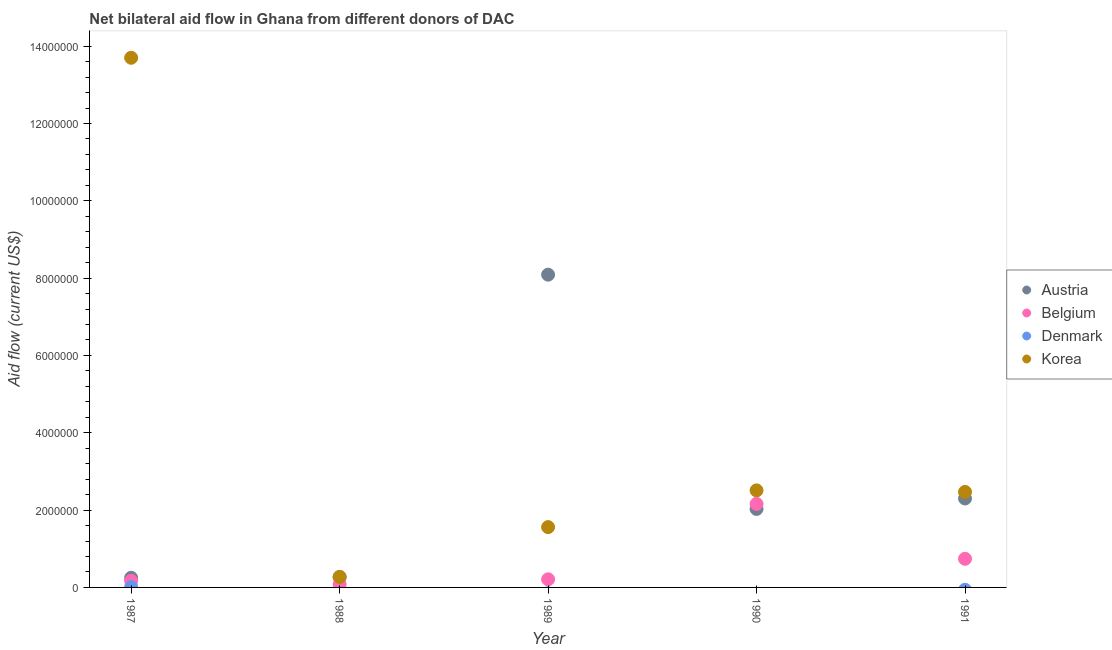How many different coloured dotlines are there?
Offer a very short reply. 4. What is the amount of aid given by belgium in 1988?
Your response must be concise. 8.00e+04. Across all years, what is the maximum amount of aid given by austria?
Offer a terse response. 8.09e+06. What is the total amount of aid given by denmark in the graph?
Your response must be concise. 10000. What is the difference between the amount of aid given by korea in 1987 and that in 1989?
Your answer should be very brief. 1.21e+07. What is the difference between the amount of aid given by denmark in 1987 and the amount of aid given by austria in 1991?
Provide a short and direct response. -2.29e+06. What is the average amount of aid given by denmark per year?
Offer a very short reply. 2000. In the year 1989, what is the difference between the amount of aid given by belgium and amount of aid given by korea?
Your answer should be very brief. -1.35e+06. What is the ratio of the amount of aid given by belgium in 1989 to that in 1990?
Your answer should be compact. 0.1. Is the amount of aid given by korea in 1990 less than that in 1991?
Offer a very short reply. No. What is the difference between the highest and the second highest amount of aid given by korea?
Give a very brief answer. 1.12e+07. What is the difference between the highest and the lowest amount of aid given by korea?
Your answer should be compact. 1.34e+07. In how many years, is the amount of aid given by korea greater than the average amount of aid given by korea taken over all years?
Keep it short and to the point. 1. Is the sum of the amount of aid given by korea in 1987 and 1990 greater than the maximum amount of aid given by belgium across all years?
Make the answer very short. Yes. Is it the case that in every year, the sum of the amount of aid given by denmark and amount of aid given by austria is greater than the sum of amount of aid given by belgium and amount of aid given by korea?
Give a very brief answer. No. Is the amount of aid given by denmark strictly greater than the amount of aid given by belgium over the years?
Ensure brevity in your answer.  No. Is the amount of aid given by belgium strictly less than the amount of aid given by austria over the years?
Provide a short and direct response. No. How many dotlines are there?
Provide a succinct answer. 4. Are the values on the major ticks of Y-axis written in scientific E-notation?
Provide a succinct answer. No. Does the graph contain any zero values?
Keep it short and to the point. Yes. Does the graph contain grids?
Your answer should be very brief. No. Where does the legend appear in the graph?
Your response must be concise. Center right. How are the legend labels stacked?
Give a very brief answer. Vertical. What is the title of the graph?
Your answer should be compact. Net bilateral aid flow in Ghana from different donors of DAC. Does "Secondary general" appear as one of the legend labels in the graph?
Your answer should be compact. No. What is the label or title of the Y-axis?
Ensure brevity in your answer.  Aid flow (current US$). What is the Aid flow (current US$) of Austria in 1987?
Give a very brief answer. 2.50e+05. What is the Aid flow (current US$) of Denmark in 1987?
Provide a succinct answer. 10000. What is the Aid flow (current US$) of Korea in 1987?
Provide a succinct answer. 1.37e+07. What is the Aid flow (current US$) in Austria in 1988?
Your answer should be very brief. 2.70e+05. What is the Aid flow (current US$) in Belgium in 1988?
Give a very brief answer. 8.00e+04. What is the Aid flow (current US$) in Denmark in 1988?
Keep it short and to the point. 0. What is the Aid flow (current US$) of Austria in 1989?
Your answer should be very brief. 8.09e+06. What is the Aid flow (current US$) of Belgium in 1989?
Provide a short and direct response. 2.10e+05. What is the Aid flow (current US$) of Korea in 1989?
Your answer should be very brief. 1.56e+06. What is the Aid flow (current US$) of Austria in 1990?
Give a very brief answer. 2.03e+06. What is the Aid flow (current US$) in Belgium in 1990?
Keep it short and to the point. 2.16e+06. What is the Aid flow (current US$) of Korea in 1990?
Give a very brief answer. 2.51e+06. What is the Aid flow (current US$) in Austria in 1991?
Your answer should be compact. 2.30e+06. What is the Aid flow (current US$) of Belgium in 1991?
Ensure brevity in your answer.  7.40e+05. What is the Aid flow (current US$) in Denmark in 1991?
Make the answer very short. 0. What is the Aid flow (current US$) in Korea in 1991?
Offer a very short reply. 2.47e+06. Across all years, what is the maximum Aid flow (current US$) of Austria?
Your answer should be compact. 8.09e+06. Across all years, what is the maximum Aid flow (current US$) in Belgium?
Your answer should be compact. 2.16e+06. Across all years, what is the maximum Aid flow (current US$) in Korea?
Ensure brevity in your answer.  1.37e+07. Across all years, what is the minimum Aid flow (current US$) of Belgium?
Ensure brevity in your answer.  8.00e+04. Across all years, what is the minimum Aid flow (current US$) in Denmark?
Offer a very short reply. 0. Across all years, what is the minimum Aid flow (current US$) in Korea?
Ensure brevity in your answer.  2.70e+05. What is the total Aid flow (current US$) of Austria in the graph?
Your response must be concise. 1.29e+07. What is the total Aid flow (current US$) in Belgium in the graph?
Your answer should be compact. 3.36e+06. What is the total Aid flow (current US$) in Korea in the graph?
Your answer should be compact. 2.05e+07. What is the difference between the Aid flow (current US$) in Austria in 1987 and that in 1988?
Keep it short and to the point. -2.00e+04. What is the difference between the Aid flow (current US$) in Korea in 1987 and that in 1988?
Provide a short and direct response. 1.34e+07. What is the difference between the Aid flow (current US$) of Austria in 1987 and that in 1989?
Keep it short and to the point. -7.84e+06. What is the difference between the Aid flow (current US$) of Korea in 1987 and that in 1989?
Ensure brevity in your answer.  1.21e+07. What is the difference between the Aid flow (current US$) in Austria in 1987 and that in 1990?
Give a very brief answer. -1.78e+06. What is the difference between the Aid flow (current US$) of Belgium in 1987 and that in 1990?
Keep it short and to the point. -1.99e+06. What is the difference between the Aid flow (current US$) in Korea in 1987 and that in 1990?
Give a very brief answer. 1.12e+07. What is the difference between the Aid flow (current US$) of Austria in 1987 and that in 1991?
Give a very brief answer. -2.05e+06. What is the difference between the Aid flow (current US$) in Belgium in 1987 and that in 1991?
Make the answer very short. -5.70e+05. What is the difference between the Aid flow (current US$) of Korea in 1987 and that in 1991?
Keep it short and to the point. 1.12e+07. What is the difference between the Aid flow (current US$) of Austria in 1988 and that in 1989?
Provide a short and direct response. -7.82e+06. What is the difference between the Aid flow (current US$) in Korea in 1988 and that in 1989?
Keep it short and to the point. -1.29e+06. What is the difference between the Aid flow (current US$) in Austria in 1988 and that in 1990?
Your response must be concise. -1.76e+06. What is the difference between the Aid flow (current US$) of Belgium in 1988 and that in 1990?
Offer a terse response. -2.08e+06. What is the difference between the Aid flow (current US$) in Korea in 1988 and that in 1990?
Offer a very short reply. -2.24e+06. What is the difference between the Aid flow (current US$) in Austria in 1988 and that in 1991?
Your answer should be compact. -2.03e+06. What is the difference between the Aid flow (current US$) of Belgium in 1988 and that in 1991?
Offer a terse response. -6.60e+05. What is the difference between the Aid flow (current US$) of Korea in 1988 and that in 1991?
Ensure brevity in your answer.  -2.20e+06. What is the difference between the Aid flow (current US$) in Austria in 1989 and that in 1990?
Your answer should be compact. 6.06e+06. What is the difference between the Aid flow (current US$) in Belgium in 1989 and that in 1990?
Provide a short and direct response. -1.95e+06. What is the difference between the Aid flow (current US$) in Korea in 1989 and that in 1990?
Offer a terse response. -9.50e+05. What is the difference between the Aid flow (current US$) of Austria in 1989 and that in 1991?
Offer a terse response. 5.79e+06. What is the difference between the Aid flow (current US$) of Belgium in 1989 and that in 1991?
Your answer should be very brief. -5.30e+05. What is the difference between the Aid flow (current US$) of Korea in 1989 and that in 1991?
Your answer should be compact. -9.10e+05. What is the difference between the Aid flow (current US$) of Belgium in 1990 and that in 1991?
Keep it short and to the point. 1.42e+06. What is the difference between the Aid flow (current US$) of Korea in 1990 and that in 1991?
Your answer should be very brief. 4.00e+04. What is the difference between the Aid flow (current US$) in Austria in 1987 and the Aid flow (current US$) in Belgium in 1988?
Keep it short and to the point. 1.70e+05. What is the difference between the Aid flow (current US$) in Austria in 1987 and the Aid flow (current US$) in Belgium in 1989?
Your answer should be compact. 4.00e+04. What is the difference between the Aid flow (current US$) of Austria in 1987 and the Aid flow (current US$) of Korea in 1989?
Your answer should be compact. -1.31e+06. What is the difference between the Aid flow (current US$) of Belgium in 1987 and the Aid flow (current US$) of Korea in 1989?
Offer a terse response. -1.39e+06. What is the difference between the Aid flow (current US$) in Denmark in 1987 and the Aid flow (current US$) in Korea in 1989?
Provide a succinct answer. -1.55e+06. What is the difference between the Aid flow (current US$) in Austria in 1987 and the Aid flow (current US$) in Belgium in 1990?
Your answer should be very brief. -1.91e+06. What is the difference between the Aid flow (current US$) in Austria in 1987 and the Aid flow (current US$) in Korea in 1990?
Provide a short and direct response. -2.26e+06. What is the difference between the Aid flow (current US$) of Belgium in 1987 and the Aid flow (current US$) of Korea in 1990?
Provide a succinct answer. -2.34e+06. What is the difference between the Aid flow (current US$) of Denmark in 1987 and the Aid flow (current US$) of Korea in 1990?
Offer a terse response. -2.50e+06. What is the difference between the Aid flow (current US$) of Austria in 1987 and the Aid flow (current US$) of Belgium in 1991?
Offer a terse response. -4.90e+05. What is the difference between the Aid flow (current US$) of Austria in 1987 and the Aid flow (current US$) of Korea in 1991?
Ensure brevity in your answer.  -2.22e+06. What is the difference between the Aid flow (current US$) in Belgium in 1987 and the Aid flow (current US$) in Korea in 1991?
Offer a terse response. -2.30e+06. What is the difference between the Aid flow (current US$) of Denmark in 1987 and the Aid flow (current US$) of Korea in 1991?
Keep it short and to the point. -2.46e+06. What is the difference between the Aid flow (current US$) of Austria in 1988 and the Aid flow (current US$) of Belgium in 1989?
Give a very brief answer. 6.00e+04. What is the difference between the Aid flow (current US$) in Austria in 1988 and the Aid flow (current US$) in Korea in 1989?
Your answer should be very brief. -1.29e+06. What is the difference between the Aid flow (current US$) of Belgium in 1988 and the Aid flow (current US$) of Korea in 1989?
Your answer should be compact. -1.48e+06. What is the difference between the Aid flow (current US$) in Austria in 1988 and the Aid flow (current US$) in Belgium in 1990?
Offer a terse response. -1.89e+06. What is the difference between the Aid flow (current US$) of Austria in 1988 and the Aid flow (current US$) of Korea in 1990?
Keep it short and to the point. -2.24e+06. What is the difference between the Aid flow (current US$) in Belgium in 1988 and the Aid flow (current US$) in Korea in 1990?
Offer a very short reply. -2.43e+06. What is the difference between the Aid flow (current US$) in Austria in 1988 and the Aid flow (current US$) in Belgium in 1991?
Ensure brevity in your answer.  -4.70e+05. What is the difference between the Aid flow (current US$) of Austria in 1988 and the Aid flow (current US$) of Korea in 1991?
Provide a succinct answer. -2.20e+06. What is the difference between the Aid flow (current US$) in Belgium in 1988 and the Aid flow (current US$) in Korea in 1991?
Offer a very short reply. -2.39e+06. What is the difference between the Aid flow (current US$) of Austria in 1989 and the Aid flow (current US$) of Belgium in 1990?
Ensure brevity in your answer.  5.93e+06. What is the difference between the Aid flow (current US$) of Austria in 1989 and the Aid flow (current US$) of Korea in 1990?
Offer a terse response. 5.58e+06. What is the difference between the Aid flow (current US$) of Belgium in 1989 and the Aid flow (current US$) of Korea in 1990?
Offer a terse response. -2.30e+06. What is the difference between the Aid flow (current US$) in Austria in 1989 and the Aid flow (current US$) in Belgium in 1991?
Make the answer very short. 7.35e+06. What is the difference between the Aid flow (current US$) of Austria in 1989 and the Aid flow (current US$) of Korea in 1991?
Provide a short and direct response. 5.62e+06. What is the difference between the Aid flow (current US$) of Belgium in 1989 and the Aid flow (current US$) of Korea in 1991?
Provide a succinct answer. -2.26e+06. What is the difference between the Aid flow (current US$) in Austria in 1990 and the Aid flow (current US$) in Belgium in 1991?
Your response must be concise. 1.29e+06. What is the difference between the Aid flow (current US$) in Austria in 1990 and the Aid flow (current US$) in Korea in 1991?
Your response must be concise. -4.40e+05. What is the difference between the Aid flow (current US$) of Belgium in 1990 and the Aid flow (current US$) of Korea in 1991?
Make the answer very short. -3.10e+05. What is the average Aid flow (current US$) in Austria per year?
Ensure brevity in your answer.  2.59e+06. What is the average Aid flow (current US$) of Belgium per year?
Offer a very short reply. 6.72e+05. What is the average Aid flow (current US$) in Korea per year?
Offer a very short reply. 4.10e+06. In the year 1987, what is the difference between the Aid flow (current US$) in Austria and Aid flow (current US$) in Belgium?
Offer a very short reply. 8.00e+04. In the year 1987, what is the difference between the Aid flow (current US$) in Austria and Aid flow (current US$) in Korea?
Ensure brevity in your answer.  -1.34e+07. In the year 1987, what is the difference between the Aid flow (current US$) of Belgium and Aid flow (current US$) of Denmark?
Make the answer very short. 1.60e+05. In the year 1987, what is the difference between the Aid flow (current US$) of Belgium and Aid flow (current US$) of Korea?
Offer a terse response. -1.35e+07. In the year 1987, what is the difference between the Aid flow (current US$) of Denmark and Aid flow (current US$) of Korea?
Your answer should be very brief. -1.37e+07. In the year 1988, what is the difference between the Aid flow (current US$) in Austria and Aid flow (current US$) in Belgium?
Your answer should be very brief. 1.90e+05. In the year 1988, what is the difference between the Aid flow (current US$) of Austria and Aid flow (current US$) of Korea?
Provide a short and direct response. 0. In the year 1988, what is the difference between the Aid flow (current US$) of Belgium and Aid flow (current US$) of Korea?
Provide a short and direct response. -1.90e+05. In the year 1989, what is the difference between the Aid flow (current US$) in Austria and Aid flow (current US$) in Belgium?
Offer a very short reply. 7.88e+06. In the year 1989, what is the difference between the Aid flow (current US$) of Austria and Aid flow (current US$) of Korea?
Your answer should be compact. 6.53e+06. In the year 1989, what is the difference between the Aid flow (current US$) in Belgium and Aid flow (current US$) in Korea?
Provide a short and direct response. -1.35e+06. In the year 1990, what is the difference between the Aid flow (current US$) in Austria and Aid flow (current US$) in Korea?
Provide a short and direct response. -4.80e+05. In the year 1990, what is the difference between the Aid flow (current US$) of Belgium and Aid flow (current US$) of Korea?
Offer a terse response. -3.50e+05. In the year 1991, what is the difference between the Aid flow (current US$) in Austria and Aid flow (current US$) in Belgium?
Offer a terse response. 1.56e+06. In the year 1991, what is the difference between the Aid flow (current US$) of Belgium and Aid flow (current US$) of Korea?
Give a very brief answer. -1.73e+06. What is the ratio of the Aid flow (current US$) of Austria in 1987 to that in 1988?
Make the answer very short. 0.93. What is the ratio of the Aid flow (current US$) of Belgium in 1987 to that in 1988?
Make the answer very short. 2.12. What is the ratio of the Aid flow (current US$) of Korea in 1987 to that in 1988?
Your response must be concise. 50.74. What is the ratio of the Aid flow (current US$) of Austria in 1987 to that in 1989?
Provide a succinct answer. 0.03. What is the ratio of the Aid flow (current US$) of Belgium in 1987 to that in 1989?
Your answer should be compact. 0.81. What is the ratio of the Aid flow (current US$) in Korea in 1987 to that in 1989?
Your answer should be very brief. 8.78. What is the ratio of the Aid flow (current US$) of Austria in 1987 to that in 1990?
Offer a terse response. 0.12. What is the ratio of the Aid flow (current US$) of Belgium in 1987 to that in 1990?
Offer a terse response. 0.08. What is the ratio of the Aid flow (current US$) of Korea in 1987 to that in 1990?
Offer a terse response. 5.46. What is the ratio of the Aid flow (current US$) in Austria in 1987 to that in 1991?
Provide a succinct answer. 0.11. What is the ratio of the Aid flow (current US$) in Belgium in 1987 to that in 1991?
Offer a very short reply. 0.23. What is the ratio of the Aid flow (current US$) in Korea in 1987 to that in 1991?
Provide a short and direct response. 5.55. What is the ratio of the Aid flow (current US$) in Austria in 1988 to that in 1989?
Make the answer very short. 0.03. What is the ratio of the Aid flow (current US$) in Belgium in 1988 to that in 1989?
Your answer should be very brief. 0.38. What is the ratio of the Aid flow (current US$) of Korea in 1988 to that in 1989?
Your answer should be compact. 0.17. What is the ratio of the Aid flow (current US$) of Austria in 1988 to that in 1990?
Offer a terse response. 0.13. What is the ratio of the Aid flow (current US$) of Belgium in 1988 to that in 1990?
Your response must be concise. 0.04. What is the ratio of the Aid flow (current US$) of Korea in 1988 to that in 1990?
Offer a terse response. 0.11. What is the ratio of the Aid flow (current US$) in Austria in 1988 to that in 1991?
Your response must be concise. 0.12. What is the ratio of the Aid flow (current US$) of Belgium in 1988 to that in 1991?
Make the answer very short. 0.11. What is the ratio of the Aid flow (current US$) in Korea in 1988 to that in 1991?
Offer a very short reply. 0.11. What is the ratio of the Aid flow (current US$) in Austria in 1989 to that in 1990?
Offer a very short reply. 3.99. What is the ratio of the Aid flow (current US$) in Belgium in 1989 to that in 1990?
Make the answer very short. 0.1. What is the ratio of the Aid flow (current US$) of Korea in 1989 to that in 1990?
Offer a terse response. 0.62. What is the ratio of the Aid flow (current US$) in Austria in 1989 to that in 1991?
Your answer should be compact. 3.52. What is the ratio of the Aid flow (current US$) in Belgium in 1989 to that in 1991?
Ensure brevity in your answer.  0.28. What is the ratio of the Aid flow (current US$) of Korea in 1989 to that in 1991?
Ensure brevity in your answer.  0.63. What is the ratio of the Aid flow (current US$) in Austria in 1990 to that in 1991?
Ensure brevity in your answer.  0.88. What is the ratio of the Aid flow (current US$) in Belgium in 1990 to that in 1991?
Provide a succinct answer. 2.92. What is the ratio of the Aid flow (current US$) in Korea in 1990 to that in 1991?
Give a very brief answer. 1.02. What is the difference between the highest and the second highest Aid flow (current US$) of Austria?
Provide a short and direct response. 5.79e+06. What is the difference between the highest and the second highest Aid flow (current US$) in Belgium?
Ensure brevity in your answer.  1.42e+06. What is the difference between the highest and the second highest Aid flow (current US$) of Korea?
Your response must be concise. 1.12e+07. What is the difference between the highest and the lowest Aid flow (current US$) in Austria?
Provide a short and direct response. 7.84e+06. What is the difference between the highest and the lowest Aid flow (current US$) of Belgium?
Give a very brief answer. 2.08e+06. What is the difference between the highest and the lowest Aid flow (current US$) of Denmark?
Offer a very short reply. 10000. What is the difference between the highest and the lowest Aid flow (current US$) of Korea?
Provide a succinct answer. 1.34e+07. 